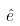Convert formula to latex. <formula><loc_0><loc_0><loc_500><loc_500>\hat { e }</formula> 